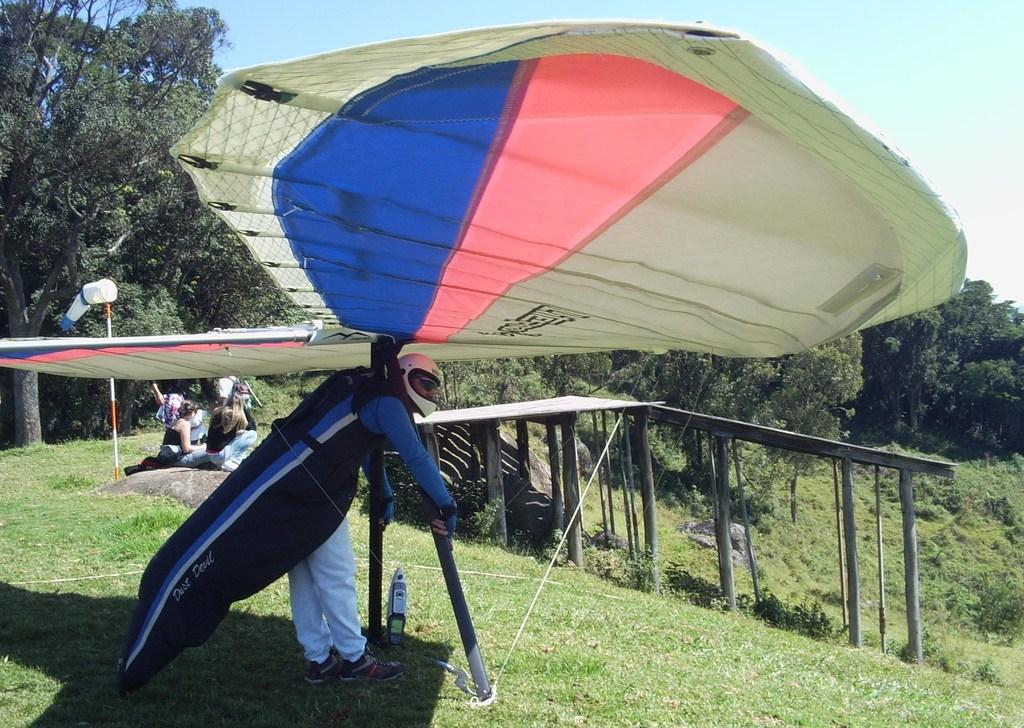What is the man in the image wearing on his head? The man in the image is wearing a helmet. What is the man's position in relation to the ground? The man is standing on the ground. What type of objects can be seen in the image besides the man? Wooden poles and trees are visible in the image. What are the people in the image doing? The people are sitting on rocks in the image. What can be seen in the background of the image? The sky is visible in the background of the image. What type of sail can be seen on the man's head in the image? There is no sail present on the man's head in the image; he is wearing a helmet. How many experts are visible in the image? There is no mention of experts in the image, so it cannot be determined how many are present. 